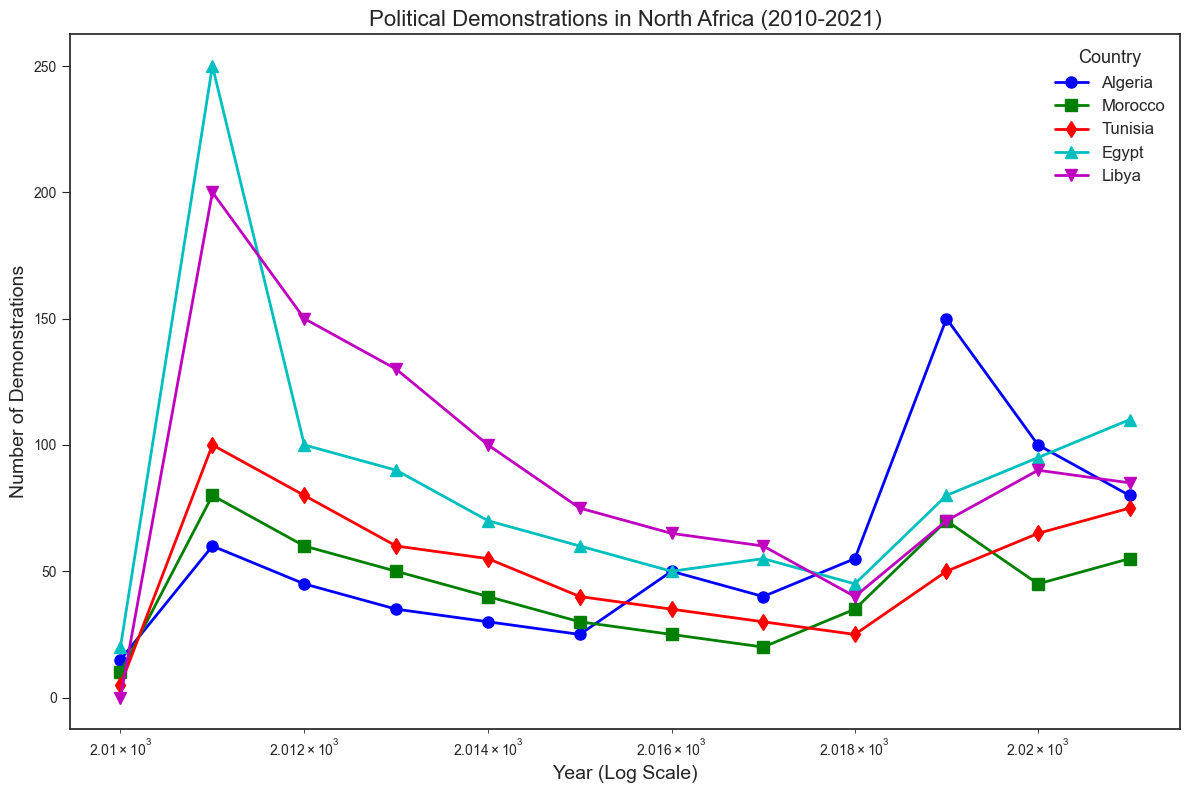What's the country with the highest number of demonstrations in 2011? Looking at the year 2011 on the x-axis and finding the highest point on the y-axis, we see that Egypt has the highest number of demonstrations with 250.
Answer: Egypt Which country experienced the largest increase in the number of demonstrations from 2018 to 2019? By comparing the number of demonstrations between 2018 and 2019, Algeria shows the largest increase (from 55 to 150).
Answer: Algeria How does the number of demonstrations in Morocco in 2017 compare to that in Tunisia in 2017? Looking at the y-values for the year 2017 for both Morocco and Tunisia, we see Morocco has 20 demonstrations and Tunisia has 30. Thus, Tunisia has more demonstrations than Morocco in 2017.
Answer: Tunisia In which year did Libya experience the peak number of demonstrations? By identifying the highest point in Libya's data series, we see the peak in 2011 with 200 demonstrations.
Answer: 2011 What is the trend of the number of demonstrations in Algeria from 2017 to 2021? From 2017 to 2021, the number of demonstrations in Algeria increased from 40 to 80, experiencing a peak in 2019 with 150 demonstrations. Overall, the trend is upward.
Answer: Upward Which country had the most stable (least fluctuating) number of demonstrations from 2010 to 2021? Examining the curves, Morocco displays the least fluctuation with a relatively stable number of demonstrations, ranging from 10 to 80.
Answer: Morocco What is the average number of demonstrations per year in Tunisia from 2015 to 2020? Summing the demonstrations in Tunisia from 2015 to 2020 and dividing by the number of years: (40 + 35 + 30 + 25 + 50 + 65) / 6 = 40.83.
Answer: 40.83 Which country saw a drop in the number of demonstrations immediately following 2011? Identifying a drop right after 2011, Egypt's number of demonstrations fell from 250 in 2011 to 100 in 2012.
Answer: Egypt 